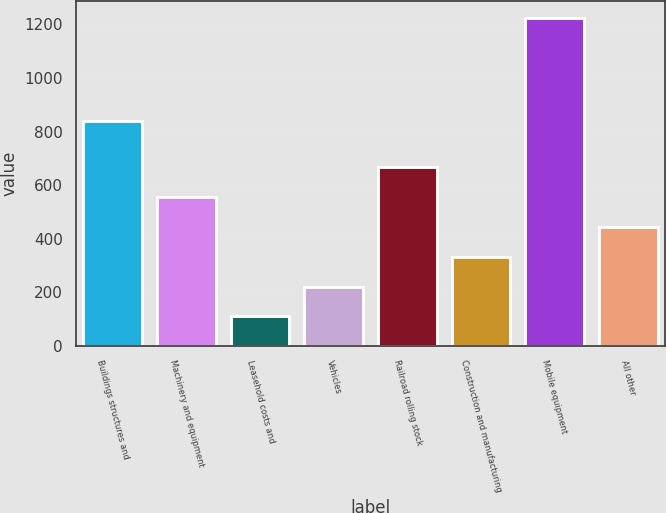Convert chart to OTSL. <chart><loc_0><loc_0><loc_500><loc_500><bar_chart><fcel>Buildings structures and<fcel>Machinery and equipment<fcel>Leasehold costs and<fcel>Vehicles<fcel>Railroad rolling stock<fcel>Construction and manufacturing<fcel>Mobile equipment<fcel>All other<nl><fcel>840<fcel>556<fcel>110<fcel>221.5<fcel>667.5<fcel>333<fcel>1225<fcel>444.5<nl></chart> 